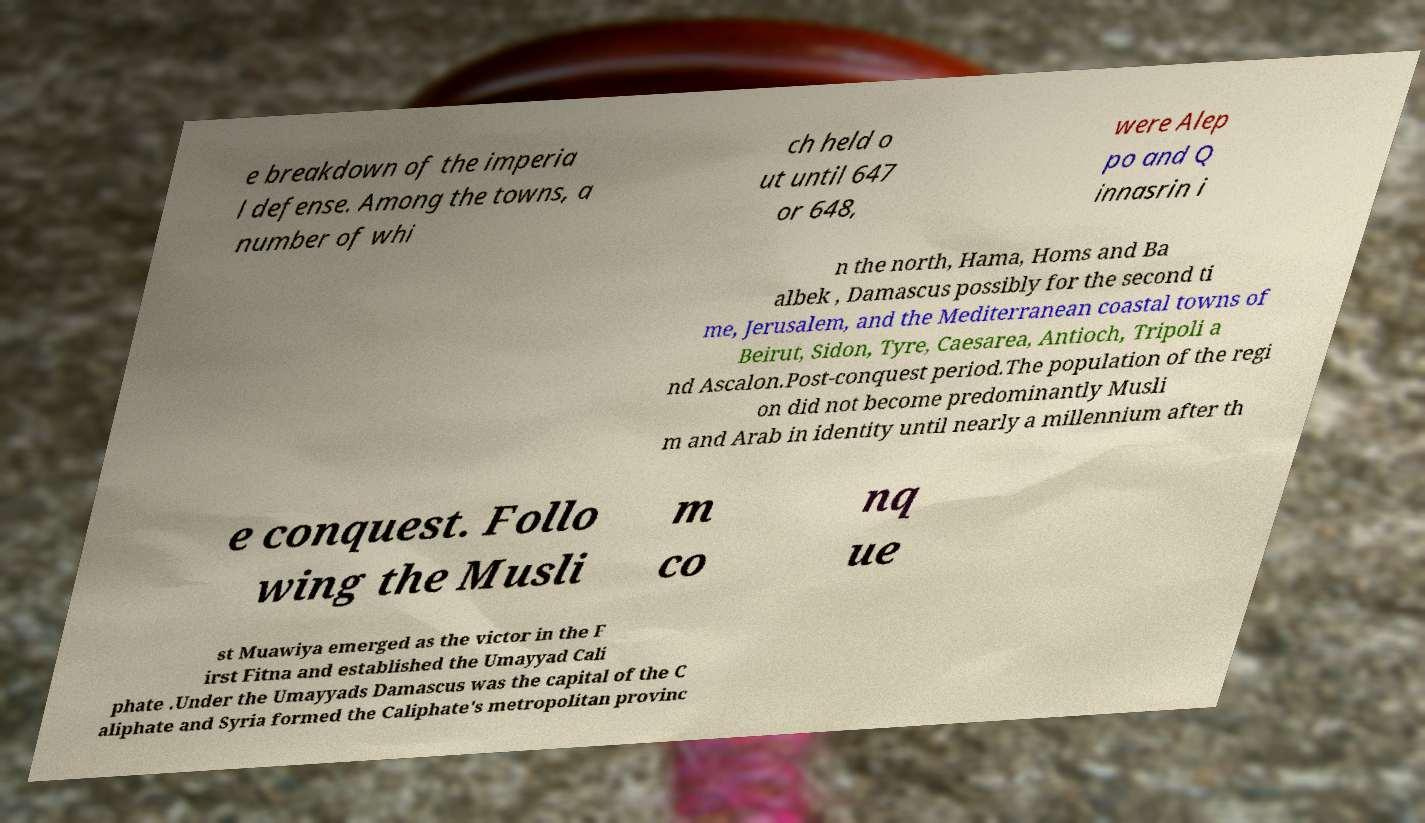Could you extract and type out the text from this image? e breakdown of the imperia l defense. Among the towns, a number of whi ch held o ut until 647 or 648, were Alep po and Q innasrin i n the north, Hama, Homs and Ba albek , Damascus possibly for the second ti me, Jerusalem, and the Mediterranean coastal towns of Beirut, Sidon, Tyre, Caesarea, Antioch, Tripoli a nd Ascalon.Post-conquest period.The population of the regi on did not become predominantly Musli m and Arab in identity until nearly a millennium after th e conquest. Follo wing the Musli m co nq ue st Muawiya emerged as the victor in the F irst Fitna and established the Umayyad Cali phate .Under the Umayyads Damascus was the capital of the C aliphate and Syria formed the Caliphate's metropolitan provinc 